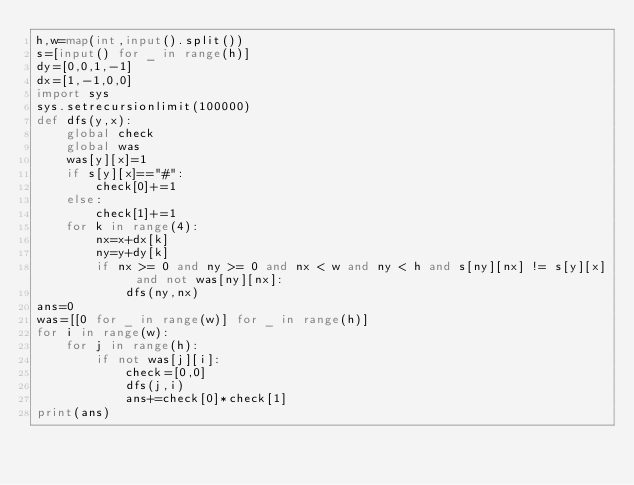Convert code to text. <code><loc_0><loc_0><loc_500><loc_500><_Python_>h,w=map(int,input().split())
s=[input() for _ in range(h)]
dy=[0,0,1,-1]
dx=[1,-1,0,0]
import sys
sys.setrecursionlimit(100000)
def dfs(y,x):
    global check
    global was
    was[y][x]=1
    if s[y][x]=="#":
        check[0]+=1
    else:
        check[1]+=1
    for k in range(4):
        nx=x+dx[k]
        ny=y+dy[k]
        if nx >= 0 and ny >= 0 and nx < w and ny < h and s[ny][nx] != s[y][x] and not was[ny][nx]:
            dfs(ny,nx) 
ans=0
was=[[0 for _ in range(w)] for _ in range(h)]
for i in range(w):
    for j in range(h):
        if not was[j][i]:
            check=[0,0]
            dfs(j,i)
            ans+=check[0]*check[1]
print(ans)</code> 